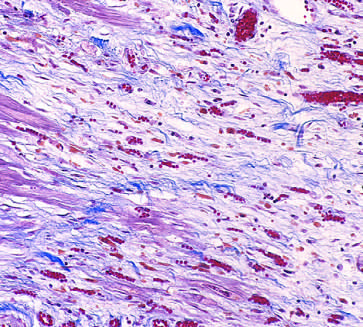what are present?
Answer the question using a single word or phrase. A few residual cardiac muscle cells 